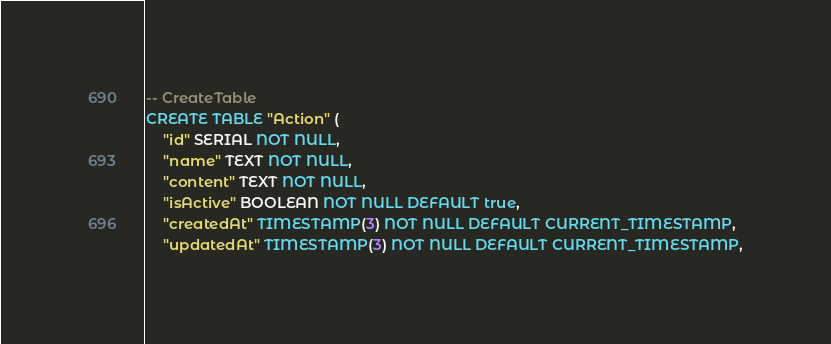Convert code to text. <code><loc_0><loc_0><loc_500><loc_500><_SQL_>-- CreateTable
CREATE TABLE "Action" (
    "id" SERIAL NOT NULL,
    "name" TEXT NOT NULL,
    "content" TEXT NOT NULL,
    "isActive" BOOLEAN NOT NULL DEFAULT true,
    "createdAt" TIMESTAMP(3) NOT NULL DEFAULT CURRENT_TIMESTAMP,
    "updatedAt" TIMESTAMP(3) NOT NULL DEFAULT CURRENT_TIMESTAMP,
</code> 